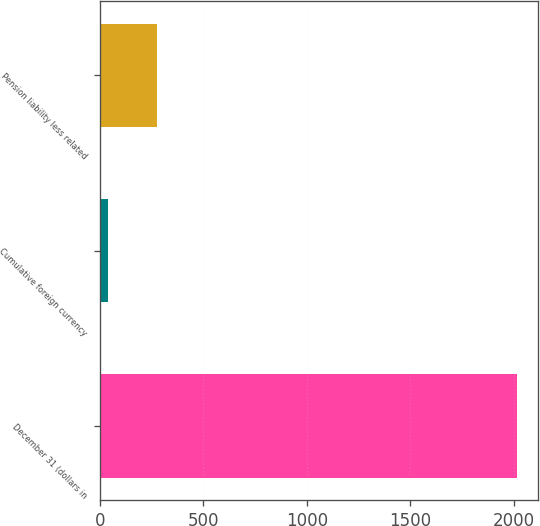Convert chart. <chart><loc_0><loc_0><loc_500><loc_500><bar_chart><fcel>December 31 (dollars in<fcel>Cumulative foreign currency<fcel>Pension liability less related<nl><fcel>2015<fcel>39.4<fcel>275.2<nl></chart> 